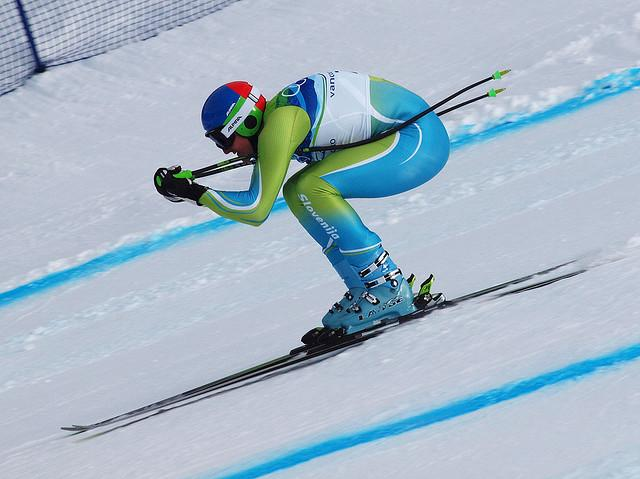What is this person trying to do?

Choices:
A) roll
B) descend
C) flip
D) ascend descend 